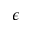<formula> <loc_0><loc_0><loc_500><loc_500>\epsilon</formula> 